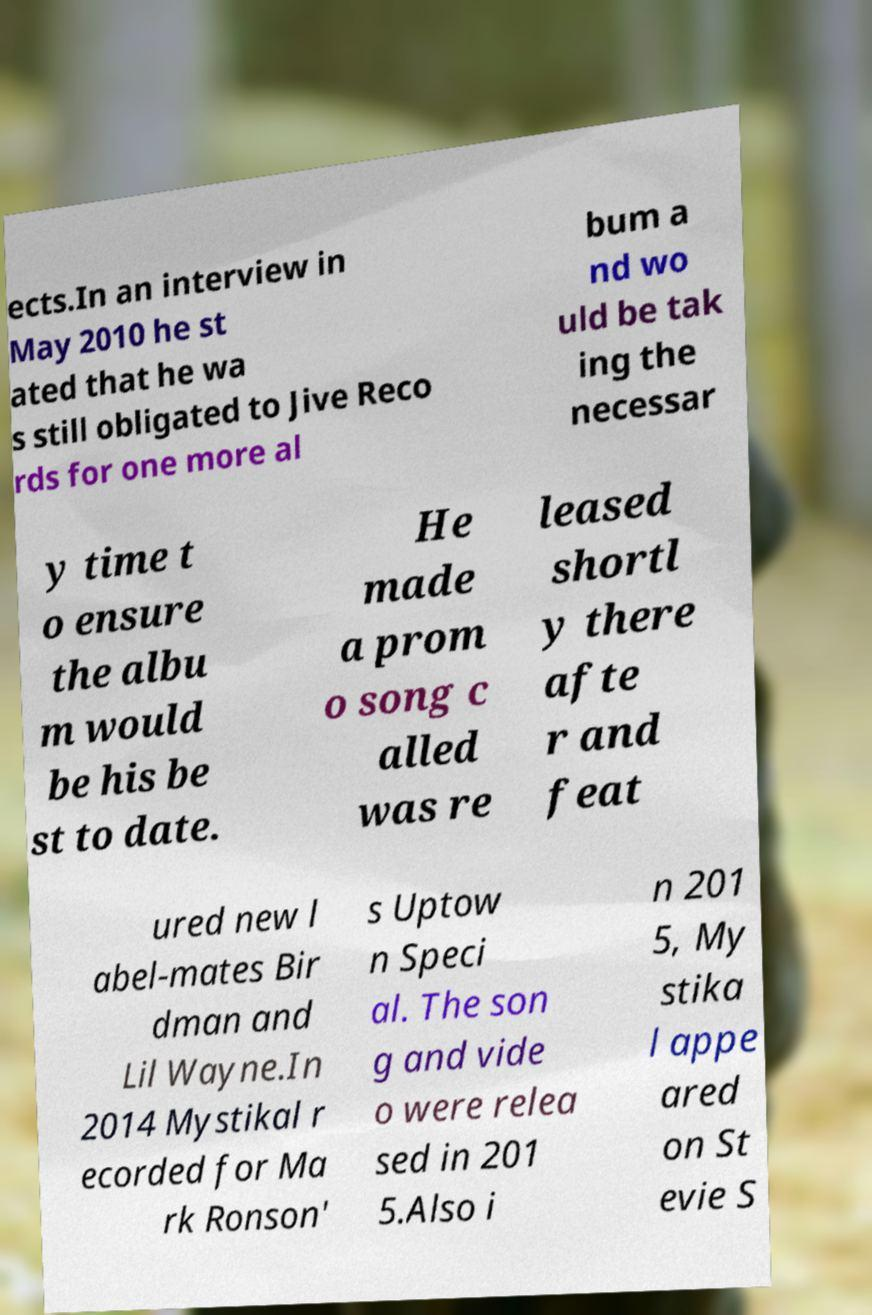Please identify and transcribe the text found in this image. ects.In an interview in May 2010 he st ated that he wa s still obligated to Jive Reco rds for one more al bum a nd wo uld be tak ing the necessar y time t o ensure the albu m would be his be st to date. He made a prom o song c alled was re leased shortl y there afte r and feat ured new l abel-mates Bir dman and Lil Wayne.In 2014 Mystikal r ecorded for Ma rk Ronson' s Uptow n Speci al. The son g and vide o were relea sed in 201 5.Also i n 201 5, My stika l appe ared on St evie S 